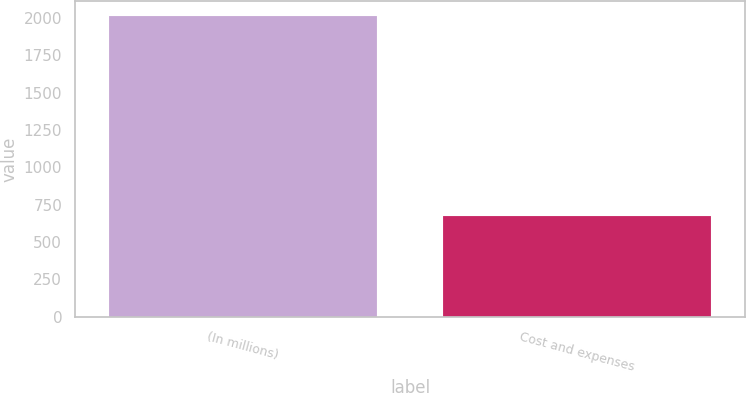Convert chart to OTSL. <chart><loc_0><loc_0><loc_500><loc_500><bar_chart><fcel>(In millions)<fcel>Cost and expenses<nl><fcel>2015<fcel>673.7<nl></chart> 